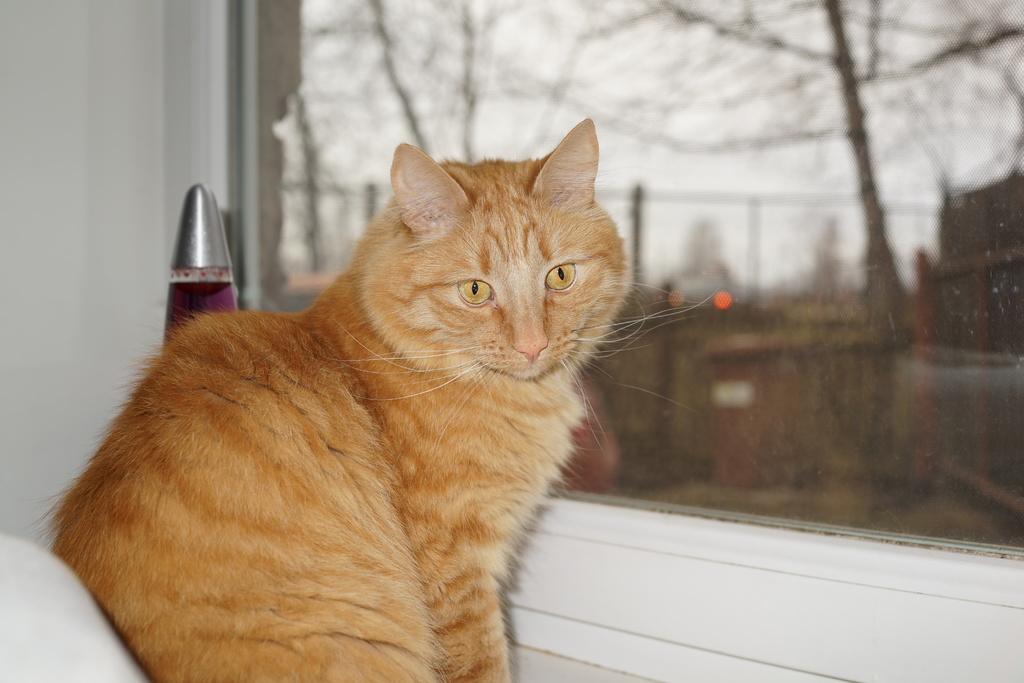In one or two sentences, can you explain what this image depicts? In this image we can see a cat. Near to the cat there is a glass window. Through the glass window we can see a blur background. 